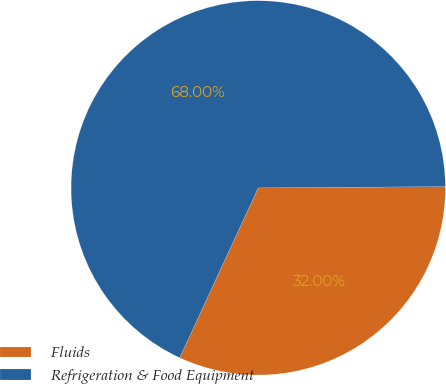Convert chart to OTSL. <chart><loc_0><loc_0><loc_500><loc_500><pie_chart><fcel>Fluids<fcel>Refrigeration & Food Equipment<nl><fcel>32.0%<fcel>68.0%<nl></chart> 